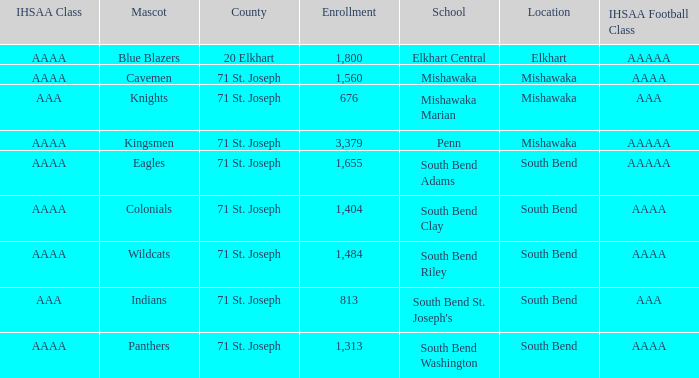What IHSAA Football Class has 20 elkhart as the county? AAAAA. 